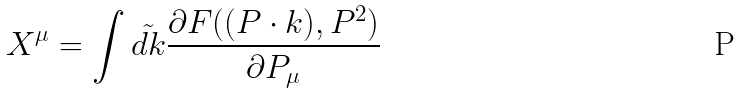<formula> <loc_0><loc_0><loc_500><loc_500>X ^ { \mu } = \int \tilde { d k } \frac { \partial F ( ( P \cdot k ) , P ^ { 2 } ) } { \partial P _ { \mu } }</formula> 